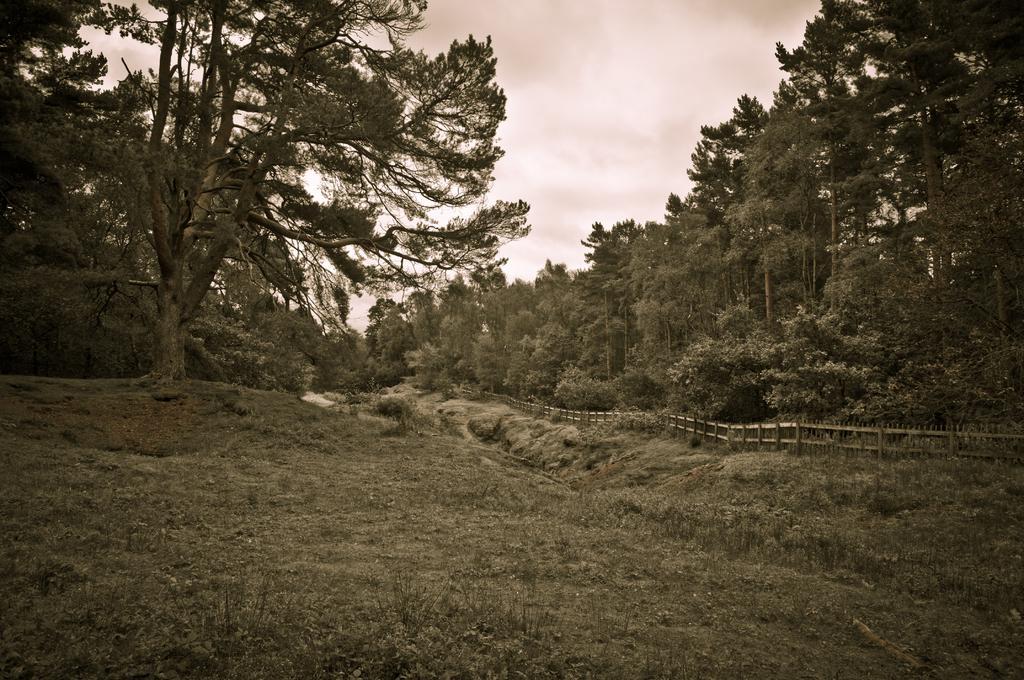How would you summarize this image in a sentence or two? In this image there are trees, plants, grass, a fence and the sky. 